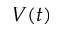<formula> <loc_0><loc_0><loc_500><loc_500>V ( t )</formula> 